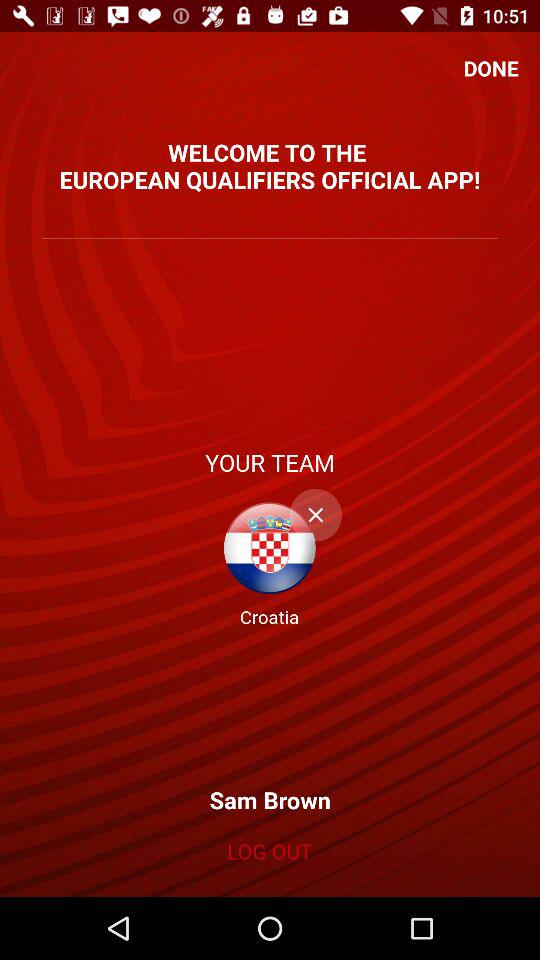What's the user name? The user name is Sam Brown. 